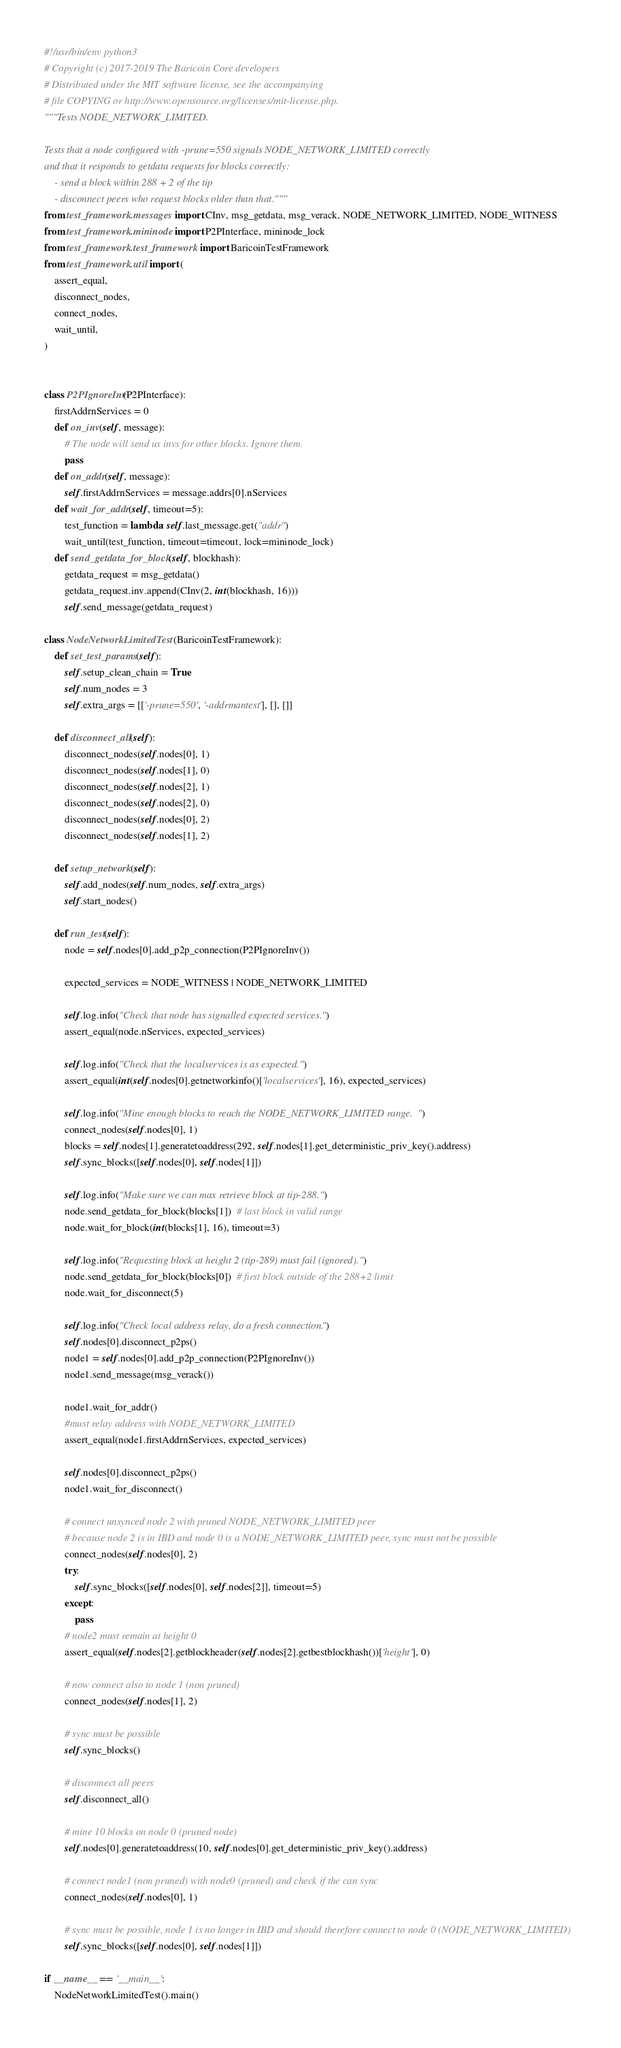<code> <loc_0><loc_0><loc_500><loc_500><_Python_>#!/usr/bin/env python3
# Copyright (c) 2017-2019 The Baricoin Core developers
# Distributed under the MIT software license, see the accompanying
# file COPYING or http://www.opensource.org/licenses/mit-license.php.
"""Tests NODE_NETWORK_LIMITED.

Tests that a node configured with -prune=550 signals NODE_NETWORK_LIMITED correctly
and that it responds to getdata requests for blocks correctly:
    - send a block within 288 + 2 of the tip
    - disconnect peers who request blocks older than that."""
from test_framework.messages import CInv, msg_getdata, msg_verack, NODE_NETWORK_LIMITED, NODE_WITNESS
from test_framework.mininode import P2PInterface, mininode_lock
from test_framework.test_framework import BaricoinTestFramework
from test_framework.util import (
    assert_equal,
    disconnect_nodes,
    connect_nodes,
    wait_until,
)


class P2PIgnoreInv(P2PInterface):
    firstAddrnServices = 0
    def on_inv(self, message):
        # The node will send us invs for other blocks. Ignore them.
        pass
    def on_addr(self, message):
        self.firstAddrnServices = message.addrs[0].nServices
    def wait_for_addr(self, timeout=5):
        test_function = lambda: self.last_message.get("addr")
        wait_until(test_function, timeout=timeout, lock=mininode_lock)
    def send_getdata_for_block(self, blockhash):
        getdata_request = msg_getdata()
        getdata_request.inv.append(CInv(2, int(blockhash, 16)))
        self.send_message(getdata_request)

class NodeNetworkLimitedTest(BaricoinTestFramework):
    def set_test_params(self):
        self.setup_clean_chain = True
        self.num_nodes = 3
        self.extra_args = [['-prune=550', '-addrmantest'], [], []]

    def disconnect_all(self):
        disconnect_nodes(self.nodes[0], 1)
        disconnect_nodes(self.nodes[1], 0)
        disconnect_nodes(self.nodes[2], 1)
        disconnect_nodes(self.nodes[2], 0)
        disconnect_nodes(self.nodes[0], 2)
        disconnect_nodes(self.nodes[1], 2)

    def setup_network(self):
        self.add_nodes(self.num_nodes, self.extra_args)
        self.start_nodes()

    def run_test(self):
        node = self.nodes[0].add_p2p_connection(P2PIgnoreInv())

        expected_services = NODE_WITNESS | NODE_NETWORK_LIMITED

        self.log.info("Check that node has signalled expected services.")
        assert_equal(node.nServices, expected_services)

        self.log.info("Check that the localservices is as expected.")
        assert_equal(int(self.nodes[0].getnetworkinfo()['localservices'], 16), expected_services)

        self.log.info("Mine enough blocks to reach the NODE_NETWORK_LIMITED range.")
        connect_nodes(self.nodes[0], 1)
        blocks = self.nodes[1].generatetoaddress(292, self.nodes[1].get_deterministic_priv_key().address)
        self.sync_blocks([self.nodes[0], self.nodes[1]])

        self.log.info("Make sure we can max retrieve block at tip-288.")
        node.send_getdata_for_block(blocks[1])  # last block in valid range
        node.wait_for_block(int(blocks[1], 16), timeout=3)

        self.log.info("Requesting block at height 2 (tip-289) must fail (ignored).")
        node.send_getdata_for_block(blocks[0])  # first block outside of the 288+2 limit
        node.wait_for_disconnect(5)

        self.log.info("Check local address relay, do a fresh connection.")
        self.nodes[0].disconnect_p2ps()
        node1 = self.nodes[0].add_p2p_connection(P2PIgnoreInv())
        node1.send_message(msg_verack())

        node1.wait_for_addr()
        #must relay address with NODE_NETWORK_LIMITED
        assert_equal(node1.firstAddrnServices, expected_services)

        self.nodes[0].disconnect_p2ps()
        node1.wait_for_disconnect()

        # connect unsynced node 2 with pruned NODE_NETWORK_LIMITED peer
        # because node 2 is in IBD and node 0 is a NODE_NETWORK_LIMITED peer, sync must not be possible
        connect_nodes(self.nodes[0], 2)
        try:
            self.sync_blocks([self.nodes[0], self.nodes[2]], timeout=5)
        except:
            pass
        # node2 must remain at height 0
        assert_equal(self.nodes[2].getblockheader(self.nodes[2].getbestblockhash())['height'], 0)

        # now connect also to node 1 (non pruned)
        connect_nodes(self.nodes[1], 2)

        # sync must be possible
        self.sync_blocks()

        # disconnect all peers
        self.disconnect_all()

        # mine 10 blocks on node 0 (pruned node)
        self.nodes[0].generatetoaddress(10, self.nodes[0].get_deterministic_priv_key().address)

        # connect node1 (non pruned) with node0 (pruned) and check if the can sync
        connect_nodes(self.nodes[0], 1)

        # sync must be possible, node 1 is no longer in IBD and should therefore connect to node 0 (NODE_NETWORK_LIMITED)
        self.sync_blocks([self.nodes[0], self.nodes[1]])

if __name__ == '__main__':
    NodeNetworkLimitedTest().main()
</code> 